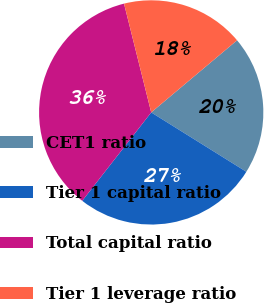Convert chart. <chart><loc_0><loc_0><loc_500><loc_500><pie_chart><fcel>CET1 ratio<fcel>Tier 1 capital ratio<fcel>Total capital ratio<fcel>Tier 1 leverage ratio<nl><fcel>20.0%<fcel>26.67%<fcel>35.56%<fcel>17.78%<nl></chart> 